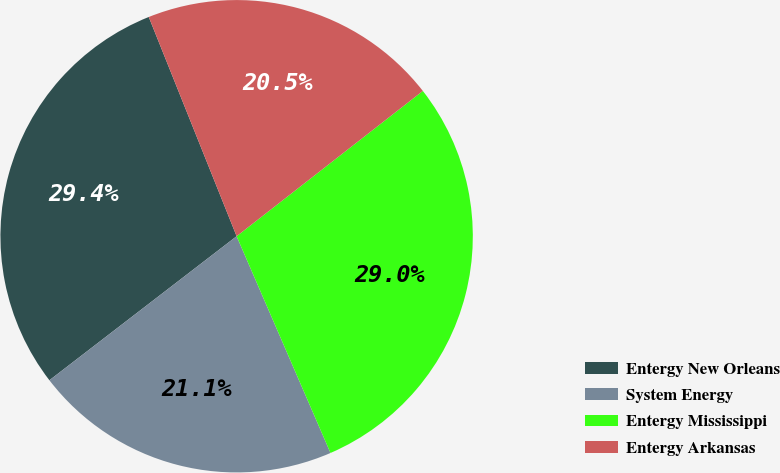Convert chart. <chart><loc_0><loc_0><loc_500><loc_500><pie_chart><fcel>Entergy New Orleans<fcel>System Energy<fcel>Entergy Mississippi<fcel>Entergy Arkansas<nl><fcel>29.37%<fcel>21.07%<fcel>29.04%<fcel>20.52%<nl></chart> 